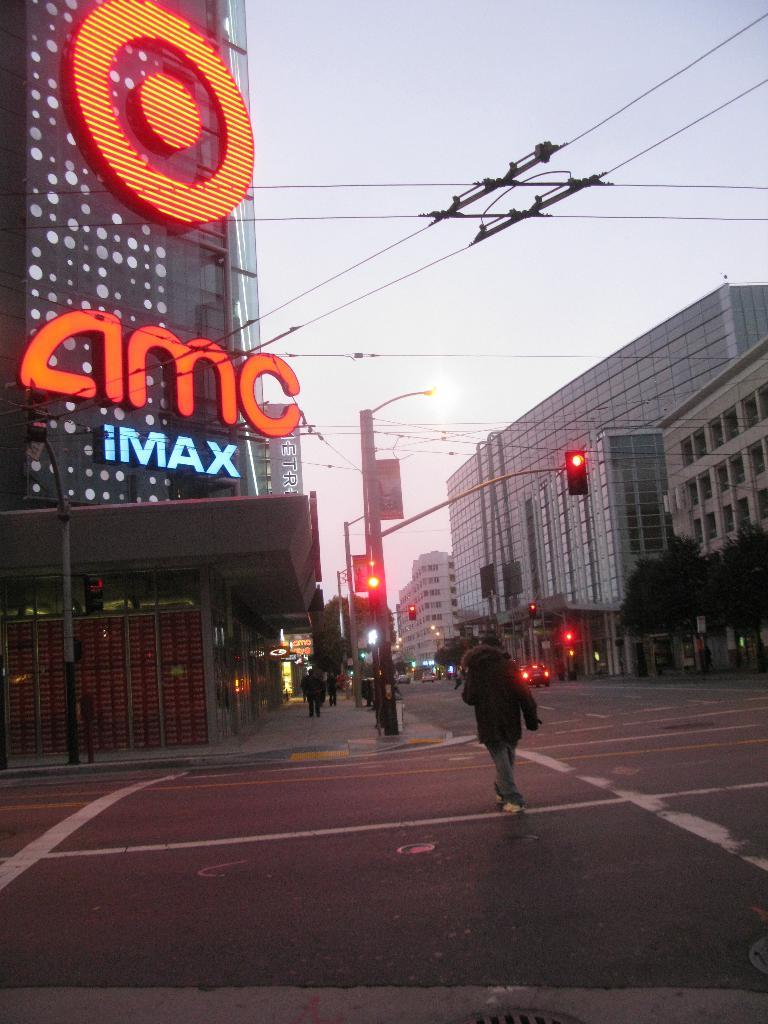Provide a one-sentence caption for the provided image. The large cinema pictured is an IMAX cinema. 